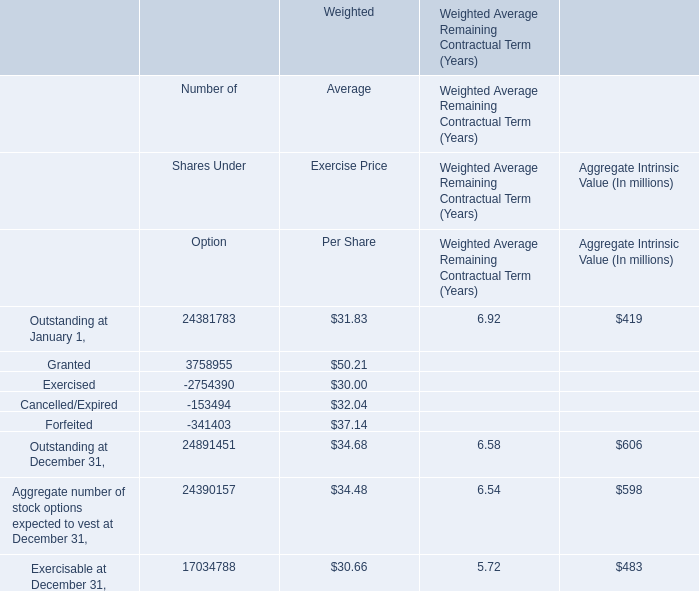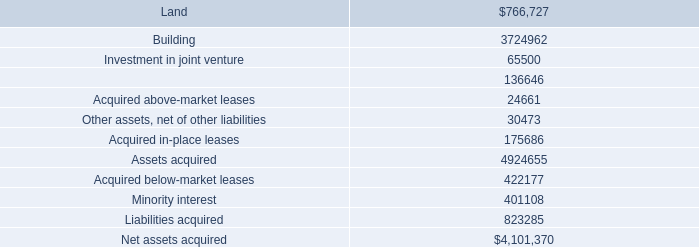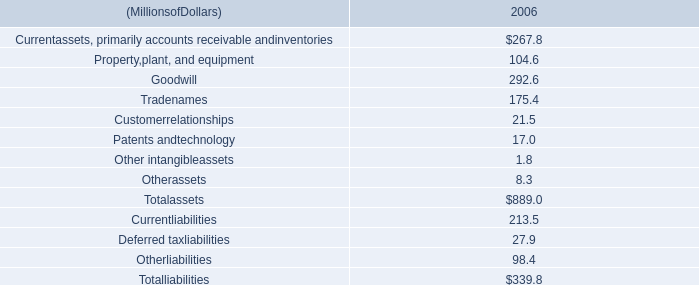What was the total amount of Granted, Exercised, Cancelled/Expired and Forfeited for Number of Shares Under Option? 
Computations: (((3758955 - 2754390) - 153494) - 341403)
Answer: 509668.0. 